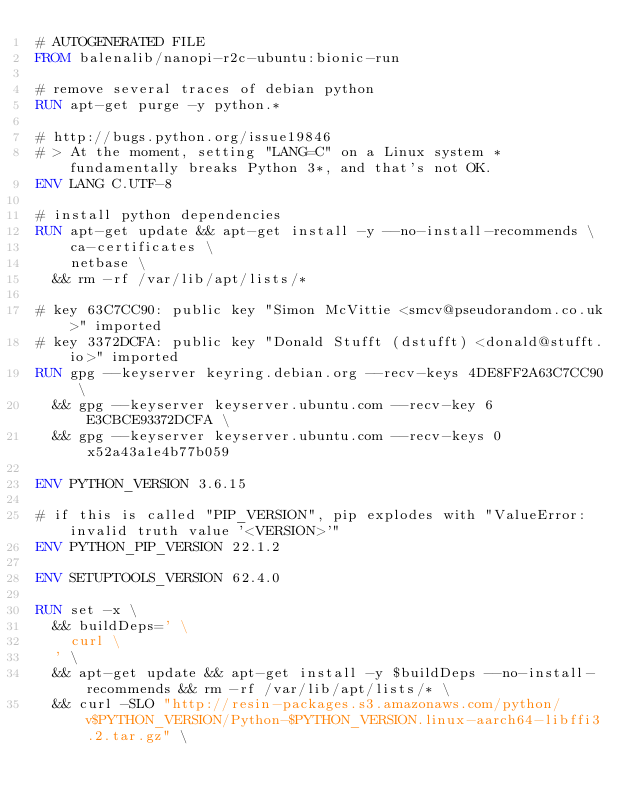<code> <loc_0><loc_0><loc_500><loc_500><_Dockerfile_># AUTOGENERATED FILE
FROM balenalib/nanopi-r2c-ubuntu:bionic-run

# remove several traces of debian python
RUN apt-get purge -y python.*

# http://bugs.python.org/issue19846
# > At the moment, setting "LANG=C" on a Linux system *fundamentally breaks Python 3*, and that's not OK.
ENV LANG C.UTF-8

# install python dependencies
RUN apt-get update && apt-get install -y --no-install-recommends \
		ca-certificates \
		netbase \
	&& rm -rf /var/lib/apt/lists/*

# key 63C7CC90: public key "Simon McVittie <smcv@pseudorandom.co.uk>" imported
# key 3372DCFA: public key "Donald Stufft (dstufft) <donald@stufft.io>" imported
RUN gpg --keyserver keyring.debian.org --recv-keys 4DE8FF2A63C7CC90 \
	&& gpg --keyserver keyserver.ubuntu.com --recv-key 6E3CBCE93372DCFA \
	&& gpg --keyserver keyserver.ubuntu.com --recv-keys 0x52a43a1e4b77b059

ENV PYTHON_VERSION 3.6.15

# if this is called "PIP_VERSION", pip explodes with "ValueError: invalid truth value '<VERSION>'"
ENV PYTHON_PIP_VERSION 22.1.2

ENV SETUPTOOLS_VERSION 62.4.0

RUN set -x \
	&& buildDeps=' \
		curl \
	' \
	&& apt-get update && apt-get install -y $buildDeps --no-install-recommends && rm -rf /var/lib/apt/lists/* \
	&& curl -SLO "http://resin-packages.s3.amazonaws.com/python/v$PYTHON_VERSION/Python-$PYTHON_VERSION.linux-aarch64-libffi3.2.tar.gz" \</code> 